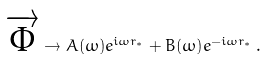Convert formula to latex. <formula><loc_0><loc_0><loc_500><loc_500>\overrightarrow { \Phi } \rightarrow { A ( \omega ) } e ^ { i \omega r _ { * } } + { B ( \omega ) } e ^ { - i \omega r _ { * } } \, .</formula> 